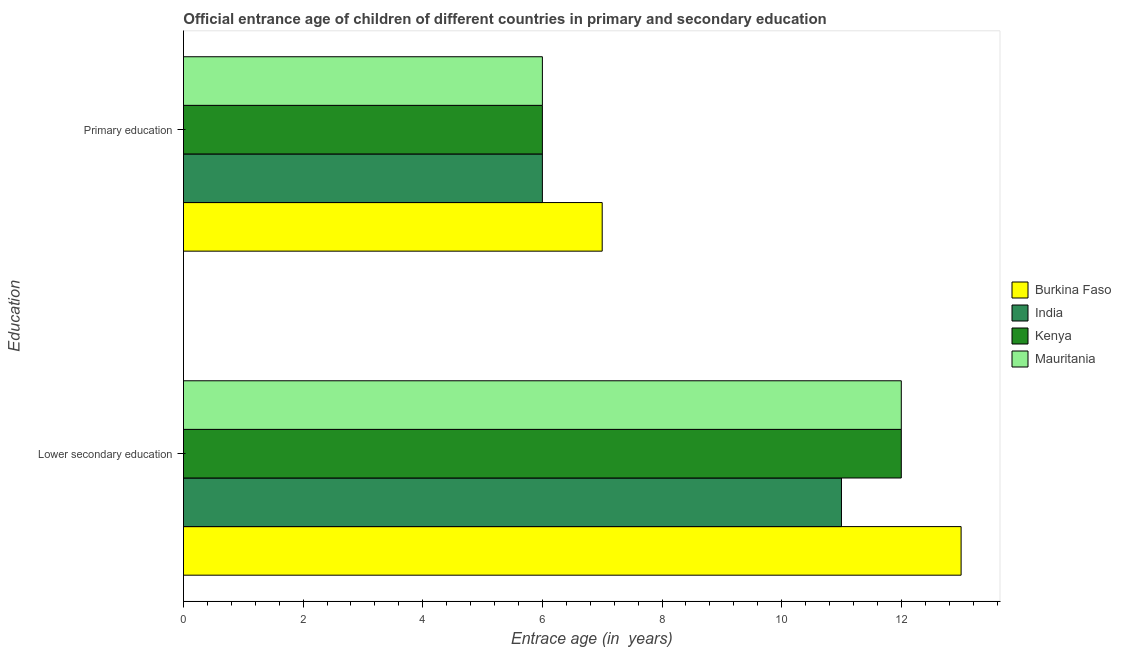How many different coloured bars are there?
Your answer should be very brief. 4. How many groups of bars are there?
Your answer should be very brief. 2. How many bars are there on the 1st tick from the top?
Provide a short and direct response. 4. What is the label of the 2nd group of bars from the top?
Your answer should be compact. Lower secondary education. What is the entrance age of chiildren in primary education in Kenya?
Your response must be concise. 6. Across all countries, what is the maximum entrance age of chiildren in primary education?
Your answer should be very brief. 7. Across all countries, what is the minimum entrance age of children in lower secondary education?
Ensure brevity in your answer.  11. In which country was the entrance age of children in lower secondary education maximum?
Ensure brevity in your answer.  Burkina Faso. In which country was the entrance age of children in lower secondary education minimum?
Offer a very short reply. India. What is the total entrance age of chiildren in primary education in the graph?
Offer a very short reply. 25. What is the difference between the entrance age of chiildren in primary education in Burkina Faso and the entrance age of children in lower secondary education in India?
Make the answer very short. -4. What is the difference between the entrance age of children in lower secondary education and entrance age of chiildren in primary education in Kenya?
Provide a short and direct response. 6. What is the ratio of the entrance age of children in lower secondary education in Kenya to that in Burkina Faso?
Offer a terse response. 0.92. Is the entrance age of children in lower secondary education in India less than that in Mauritania?
Your response must be concise. Yes. What does the 1st bar from the top in Lower secondary education represents?
Provide a succinct answer. Mauritania. How many countries are there in the graph?
Provide a succinct answer. 4. What is the difference between two consecutive major ticks on the X-axis?
Give a very brief answer. 2. Are the values on the major ticks of X-axis written in scientific E-notation?
Provide a succinct answer. No. Does the graph contain any zero values?
Your answer should be compact. No. Does the graph contain grids?
Make the answer very short. No. How many legend labels are there?
Give a very brief answer. 4. What is the title of the graph?
Keep it short and to the point. Official entrance age of children of different countries in primary and secondary education. What is the label or title of the X-axis?
Provide a short and direct response. Entrace age (in  years). What is the label or title of the Y-axis?
Give a very brief answer. Education. What is the Entrace age (in  years) in Burkina Faso in Primary education?
Ensure brevity in your answer.  7. What is the Entrace age (in  years) of India in Primary education?
Offer a terse response. 6. What is the Entrace age (in  years) in Kenya in Primary education?
Make the answer very short. 6. Across all Education, what is the maximum Entrace age (in  years) of Burkina Faso?
Offer a terse response. 13. Across all Education, what is the maximum Entrace age (in  years) in India?
Your answer should be very brief. 11. Across all Education, what is the maximum Entrace age (in  years) in Mauritania?
Provide a short and direct response. 12. Across all Education, what is the minimum Entrace age (in  years) in Mauritania?
Provide a succinct answer. 6. What is the total Entrace age (in  years) in India in the graph?
Your answer should be compact. 17. What is the total Entrace age (in  years) of Kenya in the graph?
Ensure brevity in your answer.  18. What is the difference between the Entrace age (in  years) in Burkina Faso in Lower secondary education and that in Primary education?
Offer a very short reply. 6. What is the difference between the Entrace age (in  years) in Kenya in Lower secondary education and that in Primary education?
Your answer should be very brief. 6. What is the difference between the Entrace age (in  years) of Burkina Faso in Lower secondary education and the Entrace age (in  years) of India in Primary education?
Give a very brief answer. 7. What is the difference between the Entrace age (in  years) of India in Lower secondary education and the Entrace age (in  years) of Kenya in Primary education?
Provide a succinct answer. 5. What is the difference between the Entrace age (in  years) in Kenya in Lower secondary education and the Entrace age (in  years) in Mauritania in Primary education?
Keep it short and to the point. 6. What is the average Entrace age (in  years) in Burkina Faso per Education?
Offer a very short reply. 10. What is the average Entrace age (in  years) in Kenya per Education?
Offer a terse response. 9. What is the difference between the Entrace age (in  years) in Burkina Faso and Entrace age (in  years) in Kenya in Lower secondary education?
Keep it short and to the point. 1. What is the difference between the Entrace age (in  years) of India and Entrace age (in  years) of Kenya in Lower secondary education?
Provide a succinct answer. -1. What is the difference between the Entrace age (in  years) in India and Entrace age (in  years) in Mauritania in Lower secondary education?
Offer a very short reply. -1. What is the difference between the Entrace age (in  years) of Burkina Faso and Entrace age (in  years) of India in Primary education?
Offer a very short reply. 1. What is the difference between the Entrace age (in  years) of Burkina Faso and Entrace age (in  years) of Kenya in Primary education?
Give a very brief answer. 1. What is the difference between the Entrace age (in  years) of Burkina Faso and Entrace age (in  years) of Mauritania in Primary education?
Keep it short and to the point. 1. What is the ratio of the Entrace age (in  years) in Burkina Faso in Lower secondary education to that in Primary education?
Offer a very short reply. 1.86. What is the ratio of the Entrace age (in  years) in India in Lower secondary education to that in Primary education?
Keep it short and to the point. 1.83. What is the difference between the highest and the second highest Entrace age (in  years) of Burkina Faso?
Your answer should be compact. 6. What is the difference between the highest and the second highest Entrace age (in  years) of Kenya?
Your answer should be compact. 6. What is the difference between the highest and the second highest Entrace age (in  years) of Mauritania?
Give a very brief answer. 6. What is the difference between the highest and the lowest Entrace age (in  years) in Burkina Faso?
Give a very brief answer. 6. 